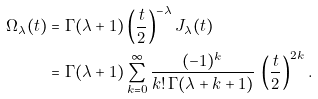Convert formula to latex. <formula><loc_0><loc_0><loc_500><loc_500>\Omega _ { \lambda } ( t ) & = \Gamma ( \lambda + 1 ) \left ( \frac { t } { 2 } \right ) ^ { - \lambda } J _ { \lambda } ( t ) \\ & = \Gamma ( \lambda + 1 ) \sum _ { k = 0 } ^ { \infty } \frac { ( - 1 ) ^ { k } } { k ! \, \Gamma ( \lambda + k + 1 ) } \, \left ( \frac { t } { 2 } \right ) ^ { 2 k } .</formula> 